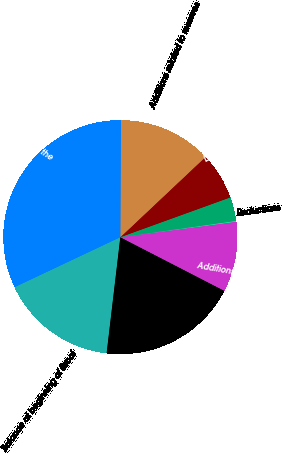Convert chart to OTSL. <chart><loc_0><loc_0><loc_500><loc_500><pie_chart><fcel>Balance at beginning of fiscal<fcel>Additions<fcel>Additions related to change in<fcel>Reductions<fcel>Payments<fcel>Lapses in statutes of<fcel>Additions related to reserves<fcel>Balance as of the end of the<nl><fcel>16.1%<fcel>19.3%<fcel>9.7%<fcel>0.1%<fcel>3.3%<fcel>6.5%<fcel>12.9%<fcel>32.11%<nl></chart> 